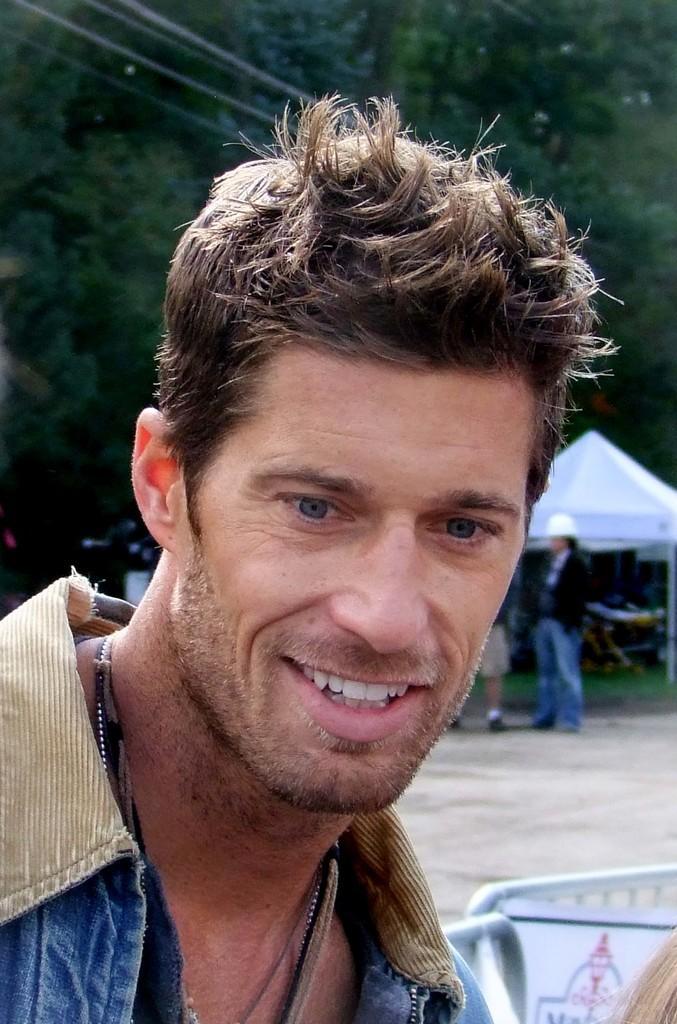Please provide a concise description of this image. In this image we can see few people. There is a tent in the image. There are few objects near the tent in the image. There are many trees in the image. There are barriers at the bottom of the image. There are few cables at the top of the image. 